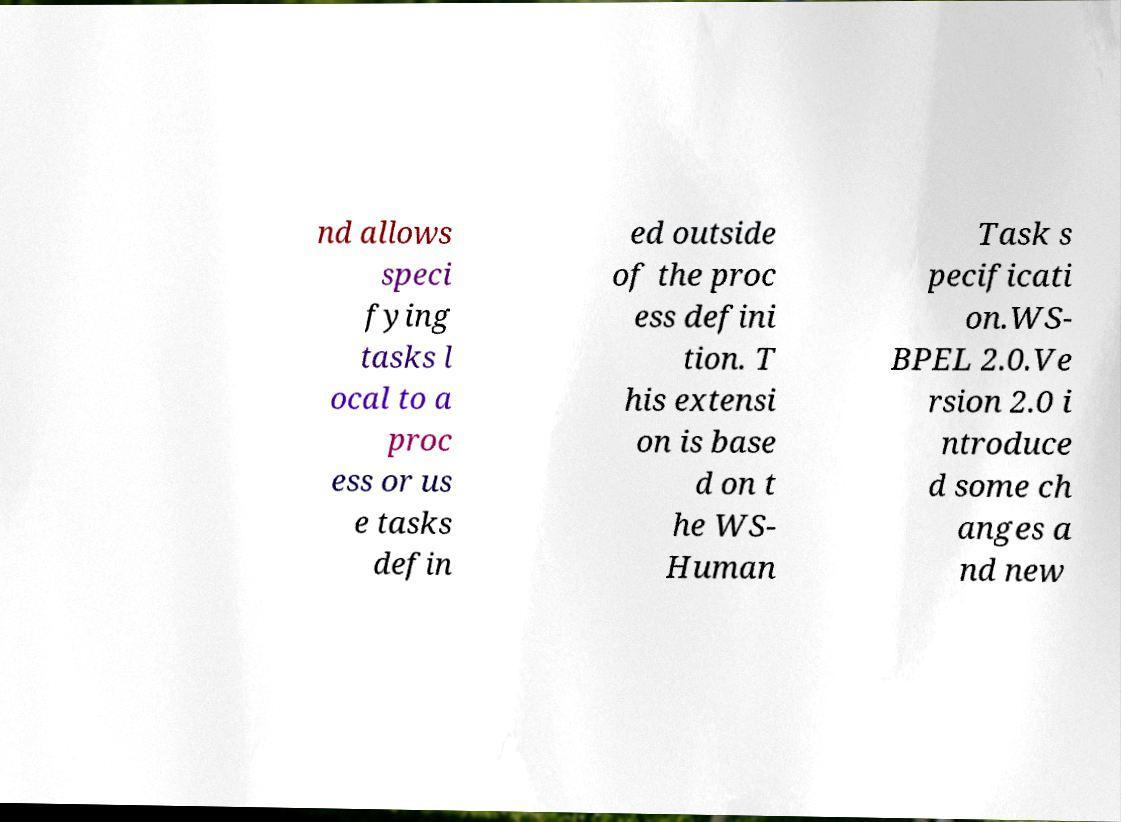Could you assist in decoding the text presented in this image and type it out clearly? nd allows speci fying tasks l ocal to a proc ess or us e tasks defin ed outside of the proc ess defini tion. T his extensi on is base d on t he WS- Human Task s pecificati on.WS- BPEL 2.0.Ve rsion 2.0 i ntroduce d some ch anges a nd new 